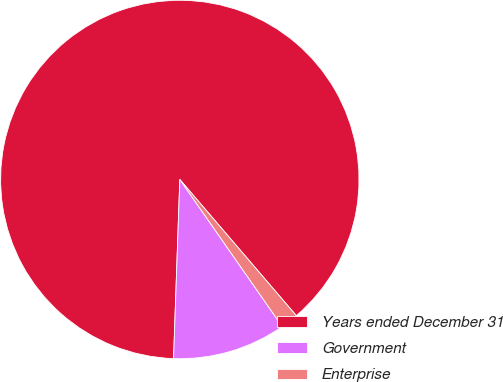<chart> <loc_0><loc_0><loc_500><loc_500><pie_chart><fcel>Years ended December 31<fcel>Government<fcel>Enterprise<nl><fcel>88.18%<fcel>10.24%<fcel>1.58%<nl></chart> 